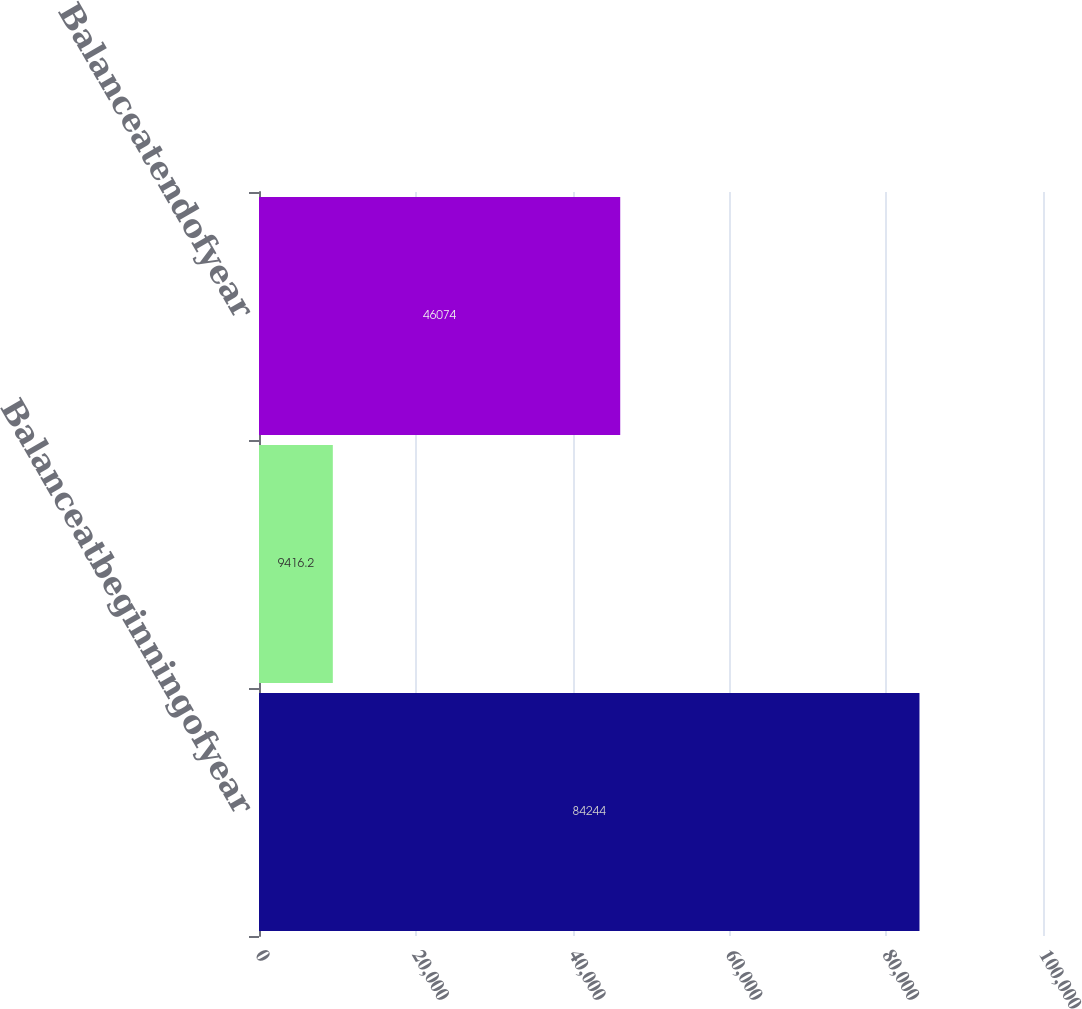Convert chart. <chart><loc_0><loc_0><loc_500><loc_500><bar_chart><fcel>Balanceatbeginningofyear<fcel>Unnamed: 1<fcel>Balanceatendofyear<nl><fcel>84244<fcel>9416.2<fcel>46074<nl></chart> 